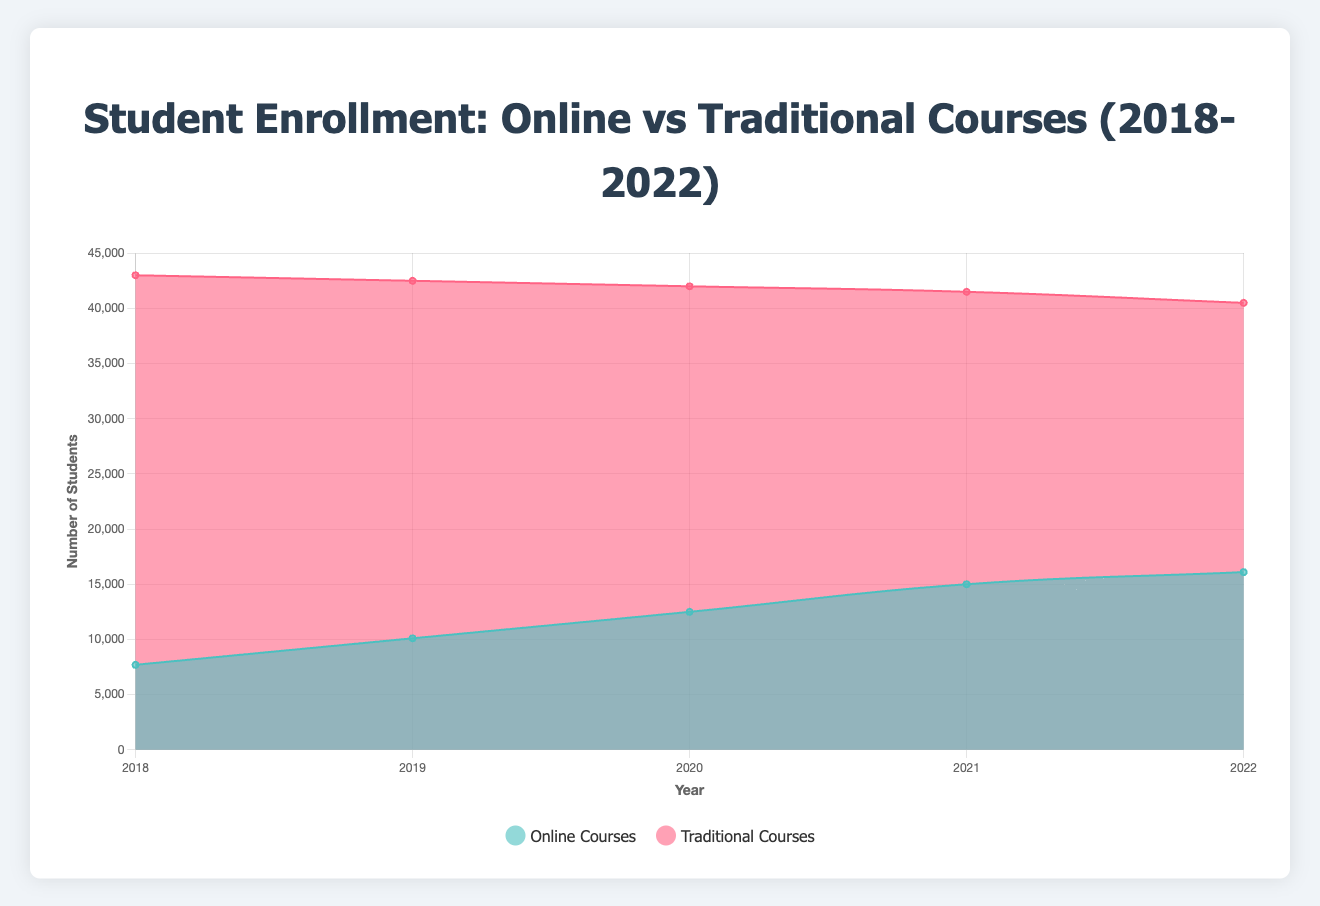What are the two course types compared in the figure? The figure compares student enrollments in Online Courses and Traditional Courses across five universities over five years.
Answer: Online Courses, Traditional Courses What has been the trend for student enrollment in online courses for Stanford University between 2018 and 2022? The trend shows that enrollment in online courses at Stanford University has consistently increased from 1500 in 2018 to 3200 in 2022, indicating a steady rise in online course adoption.
Answer: Increasing How did the total student enrollment in traditional courses across all universities change from 2018 to 2022? The total enrollment in traditional courses showed a decreasing trend. Sum the values for each year and compare: 43000 in 2018, 42400 in 2019, 41800 in 2020, 41200 in 2021, and 40500 in 2022. This indicates a steady decline in traditional course enrollment.
Answer: Decreasing Which university had the highest online course enrollment in 2022? Compare the 2022 online course enrollment numbers across all universities. Harvard University had the highest with 3500 enrollments.
Answer: Harvard University Was there any year when the online enrollment for MIT was greater than Harvard University's online enrollment? Review the online enrollments for MIT and Harvard University for each year. Harvard University's enrollments were higher than MIT's each year from 2018 to 2022.
Answer: No What is the combined enrollment for online courses in 2020 for all universities? Sum the online enrollments in 2020 for all universities: Stanford University (2500), Harvard University (2800), MIT (2200), University of California, Berkeley (2600), and University of Pennsylvania (2400). Combined, the total is 2500 + 2800 + 2200 + 2600 + 2400 = 12500 students.
Answer: 12500 How do the trends in online and traditional course enrollments differ overall from 2018 to 2022? Online course enrollments showed a rising trend for all universities, whereas traditional course enrollments showed a declining trend. This indicates a shift towards online learning over the five-year period.
Answer: Online enrollments increasing, traditional enrollments decreasing Which university had the smallest difference between online and traditional course enrollments in 2021? Calculate the difference between the online and traditional course enrollments for 2021 across all universities. Stanford University had a difference of 4700, Harvard University had 4900, MIT had 6000, University of California, Berkeley had 6100, and University of Pennsylvania had 4800. Stanford University had the smallest difference.
Answer: Stanford University 